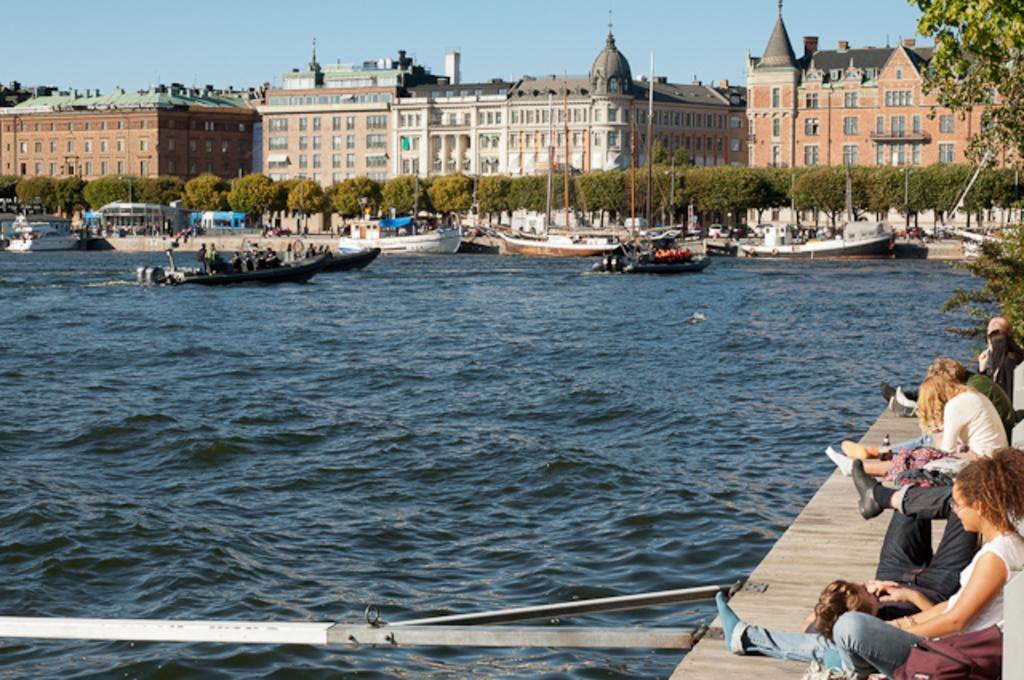Please provide a concise description of this image. There are group of people sitting on the wooden path. This looks like an iron pole. I can see the boats on the water. These are the buildings with windows. I can see the trees. 